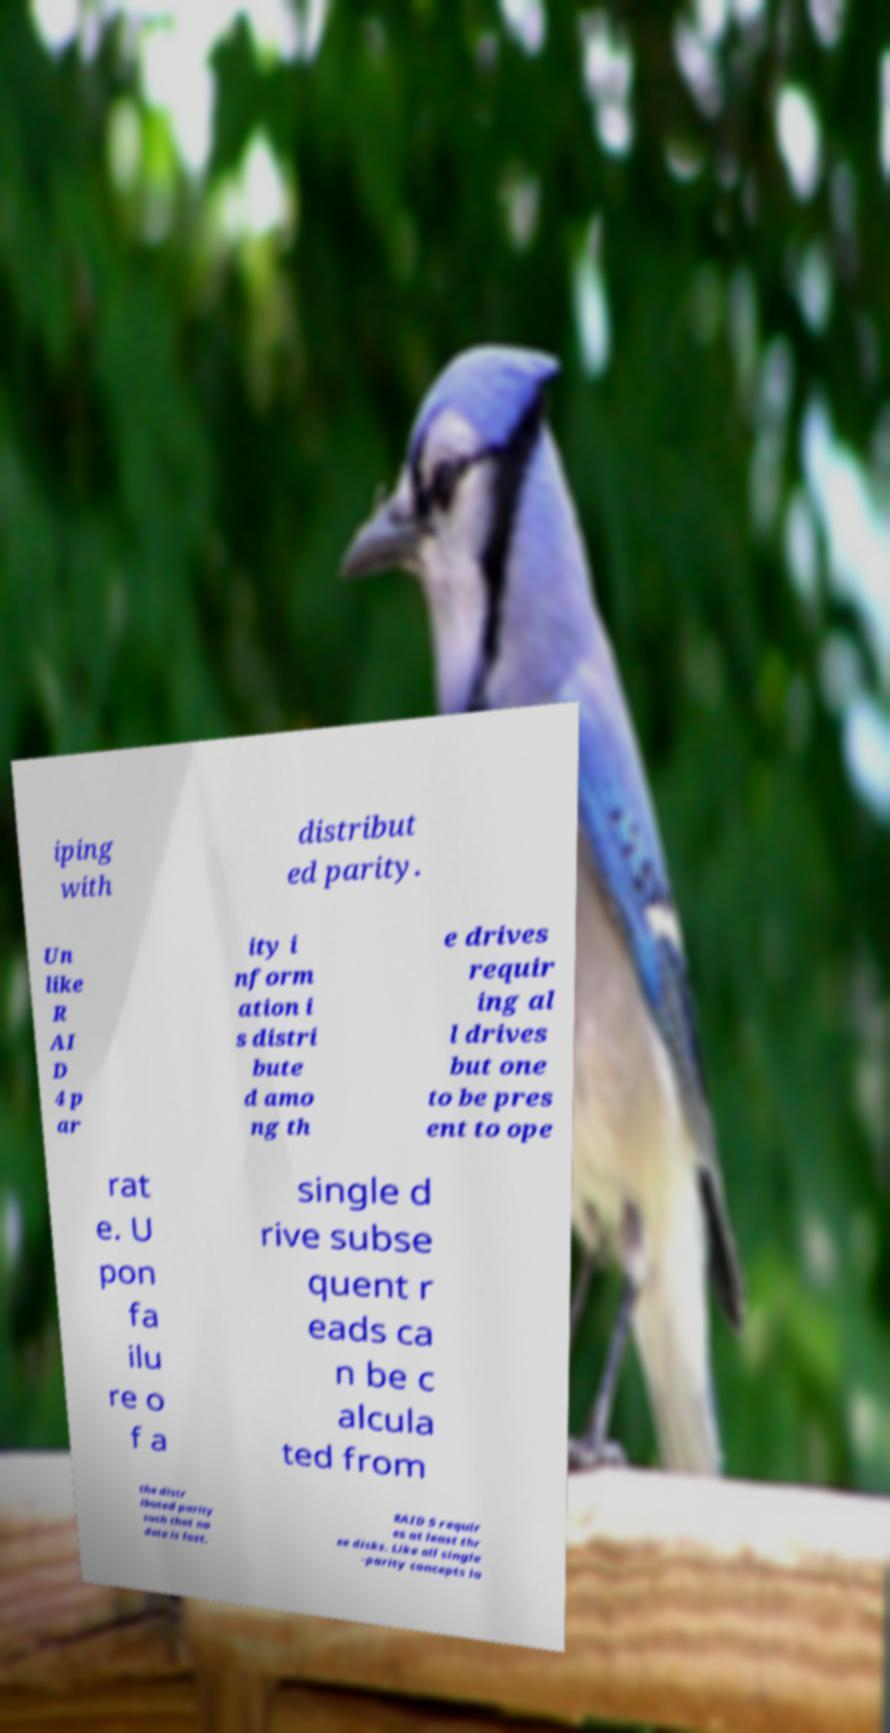Please read and relay the text visible in this image. What does it say? iping with distribut ed parity. Un like R AI D 4 p ar ity i nform ation i s distri bute d amo ng th e drives requir ing al l drives but one to be pres ent to ope rat e. U pon fa ilu re o f a single d rive subse quent r eads ca n be c alcula ted from the distr ibuted parity such that no data is lost. RAID 5 requir es at least thr ee disks. Like all single -parity concepts la 